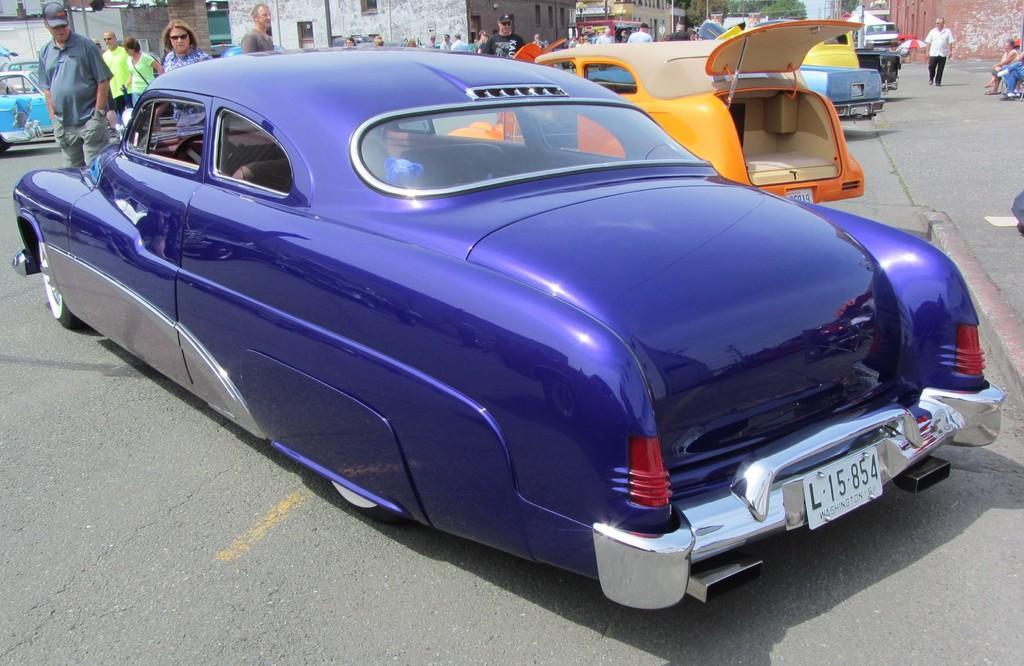How would you summarize this image in a sentence or two? In this image we can see vehicles on the road, few persons are standing and walking on the road and on the right side there are few persons sitting on a platform. In the background there are buildings, poles, trees, objects and sky. 